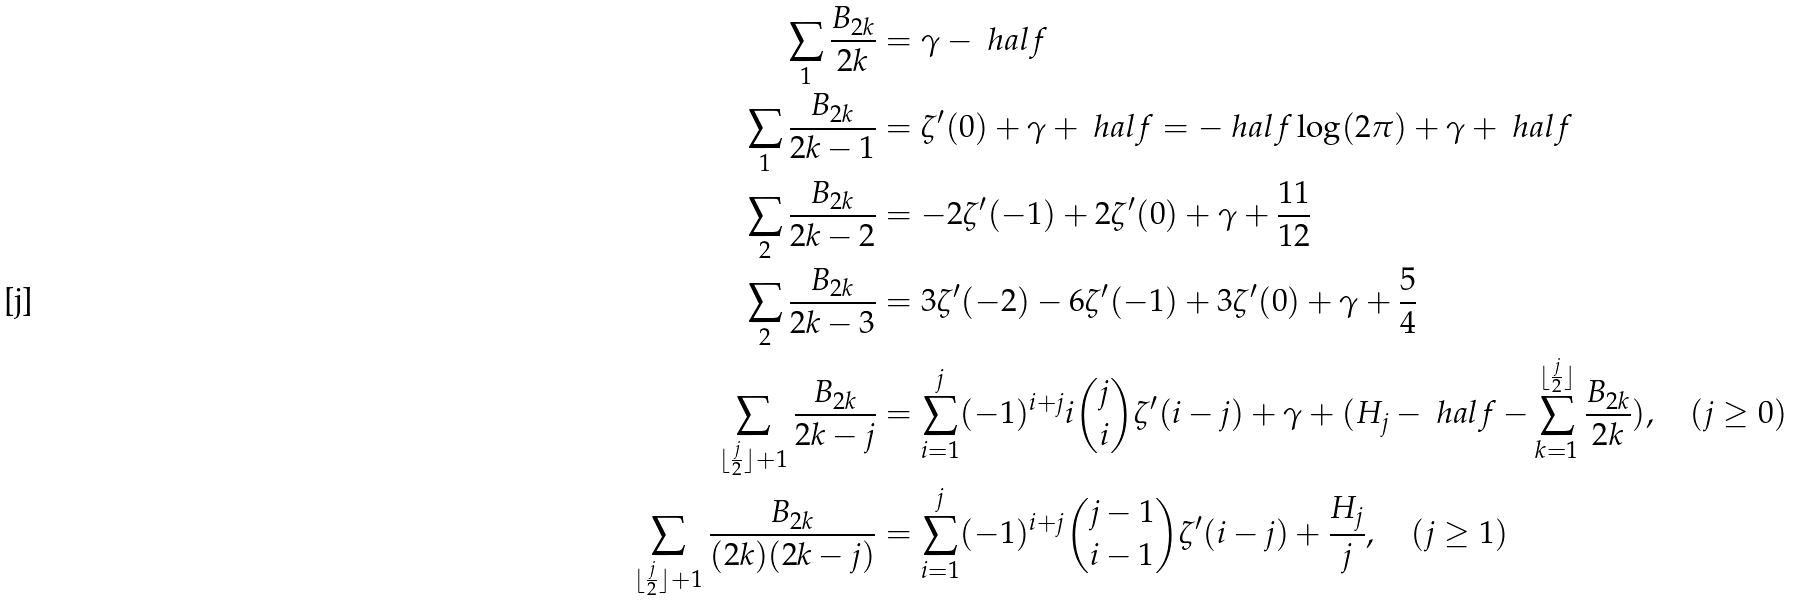<formula> <loc_0><loc_0><loc_500><loc_500>\sum _ { 1 } \frac { B _ { 2 k } } { 2 k } & = \gamma - \ h a l f \\ \sum _ { 1 } \frac { B _ { 2 k } } { 2 k - 1 } & = \zeta ^ { \prime } ( 0 ) + \gamma + \ h a l f = - \ h a l f \log ( 2 \pi ) + \gamma + \ h a l f \\ \sum _ { 2 } \frac { B _ { 2 k } } { 2 k - 2 } & = - 2 \zeta ^ { \prime } ( - 1 ) + 2 \zeta ^ { \prime } ( 0 ) + \gamma + \frac { 1 1 } { 1 2 } \\ \sum _ { 2 } \frac { B _ { 2 k } } { 2 k - 3 } & = 3 \zeta ^ { \prime } ( - 2 ) - 6 \zeta ^ { \prime } ( - 1 ) + 3 \zeta ^ { \prime } ( 0 ) + \gamma + \frac { 5 } { 4 } \\ \sum _ { \lfloor \frac { j } { 2 } \rfloor + 1 } \frac { B _ { 2 k } } { 2 k - j } & = \sum _ { i = 1 } ^ { j } ( - 1 ) ^ { i + j } i { j \choose i } \zeta ^ { \prime } ( i - j ) + \gamma + ( H _ { j } - \ h a l f - { \sum _ { k = 1 } ^ { \lfloor \frac { j } { 2 } \rfloor } \frac { B _ { 2 k } } { 2 k } } ) , \quad ( j \geq 0 ) \\ \sum _ { \lfloor \frac { j } { 2 } \rfloor + 1 } \frac { B _ { 2 k } } { ( 2 k ) ( 2 k - j ) } & = \sum _ { i = 1 } ^ { j } ( - 1 ) ^ { i + j } { j - 1 \choose i - 1 } \zeta ^ { \prime } ( i - j ) + \frac { H _ { j } } { j } , \quad ( j \geq 1 )</formula> 